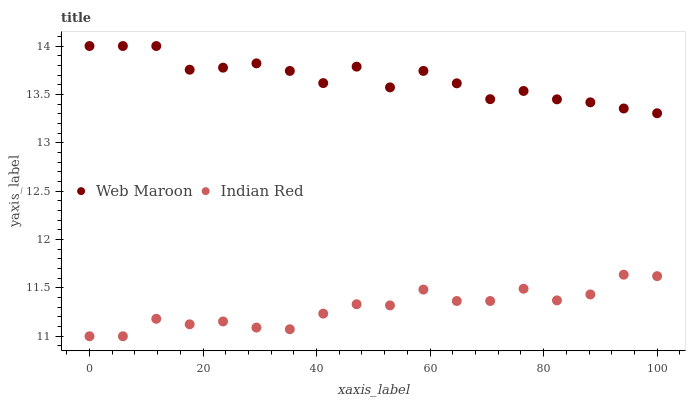Does Indian Red have the minimum area under the curve?
Answer yes or no. Yes. Does Web Maroon have the maximum area under the curve?
Answer yes or no. Yes. Does Indian Red have the maximum area under the curve?
Answer yes or no. No. Is Indian Red the smoothest?
Answer yes or no. Yes. Is Web Maroon the roughest?
Answer yes or no. Yes. Is Indian Red the roughest?
Answer yes or no. No. Does Indian Red have the lowest value?
Answer yes or no. Yes. Does Web Maroon have the highest value?
Answer yes or no. Yes. Does Indian Red have the highest value?
Answer yes or no. No. Is Indian Red less than Web Maroon?
Answer yes or no. Yes. Is Web Maroon greater than Indian Red?
Answer yes or no. Yes. Does Indian Red intersect Web Maroon?
Answer yes or no. No. 